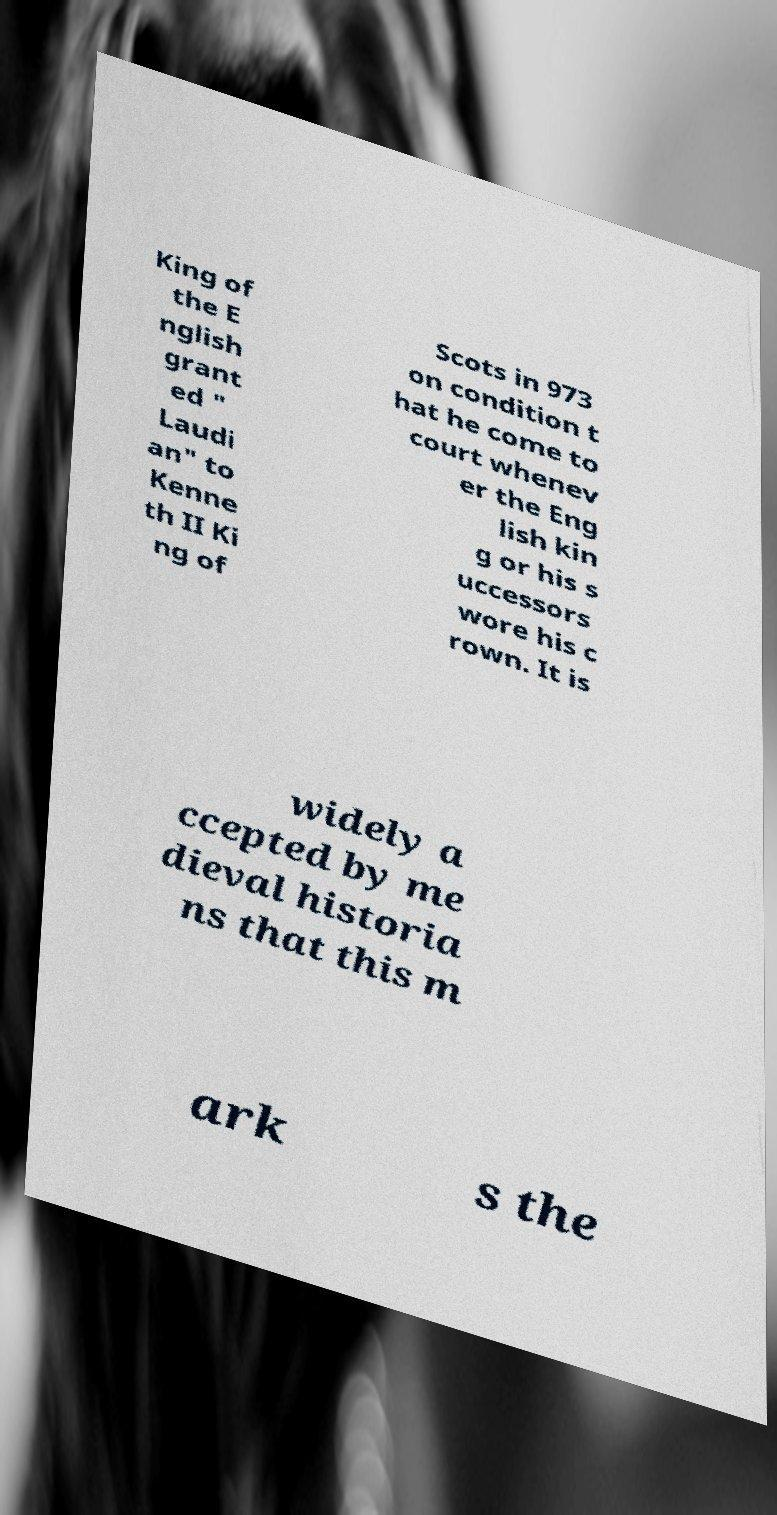I need the written content from this picture converted into text. Can you do that? King of the E nglish grant ed " Laudi an" to Kenne th II Ki ng of Scots in 973 on condition t hat he come to court whenev er the Eng lish kin g or his s uccessors wore his c rown. It is widely a ccepted by me dieval historia ns that this m ark s the 